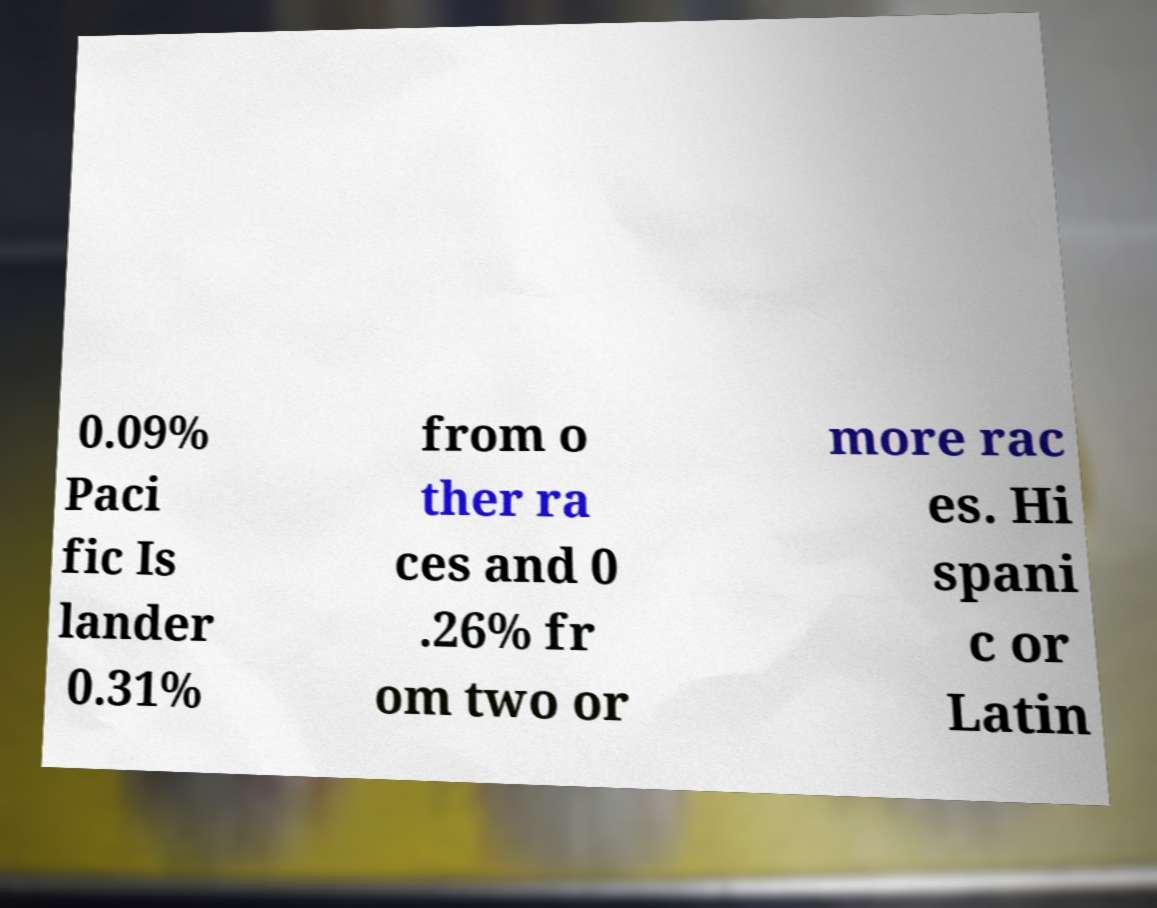I need the written content from this picture converted into text. Can you do that? 0.09% Paci fic Is lander 0.31% from o ther ra ces and 0 .26% fr om two or more rac es. Hi spani c or Latin 